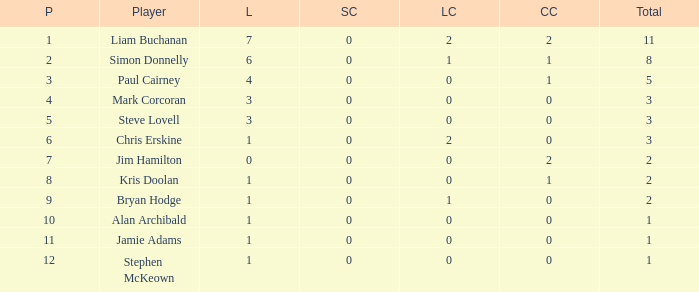What is Kris doolan's league number? 1.0. 